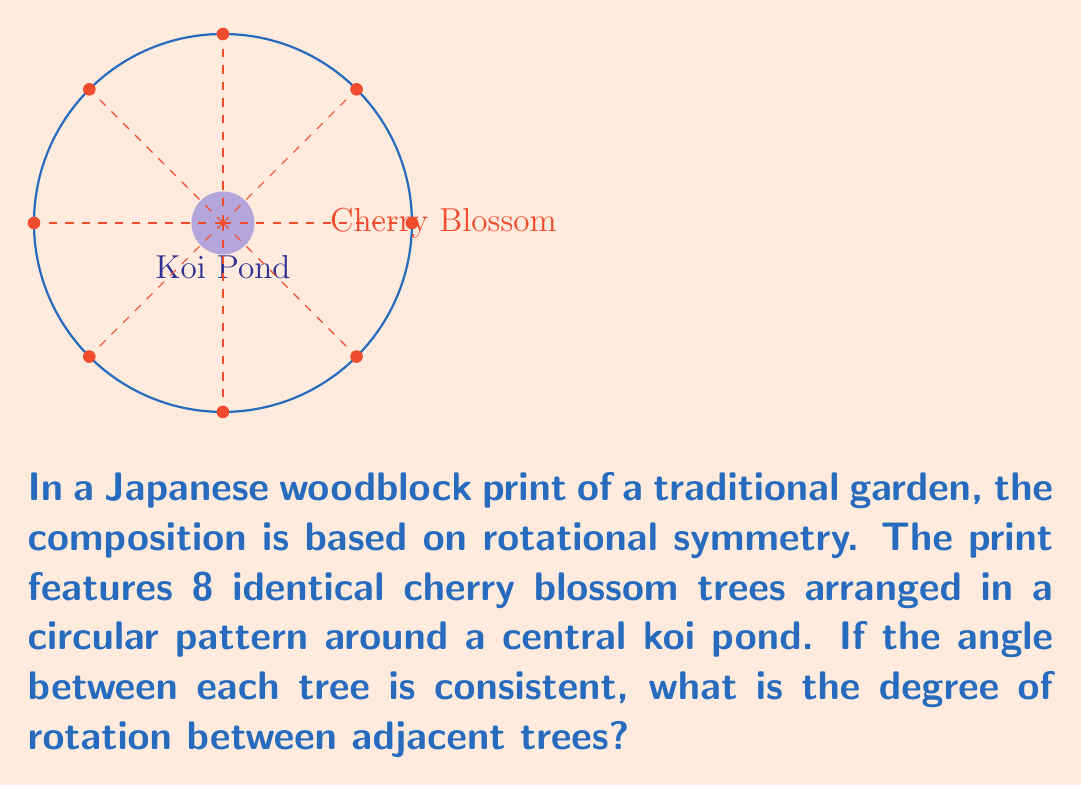Help me with this question. To solve this problem, we need to understand the concept of rotational symmetry in a circular arrangement:

1. In a complete circle, there are 360°.

2. The trees are evenly spaced around the circle, forming 8 equal segments.

3. To find the angle between adjacent trees, we need to divide the total degrees in a circle by the number of segments:

   $$\text{Angle} = \frac{\text{Total degrees}}{\text{Number of segments}}$$

4. Substituting the values:

   $$\text{Angle} = \frac{360°}{8} = 45°$$

This result aligns with the artistic principle of balance in Japanese woodblock prints, where symmetry often plays a crucial role in composition. The 45° rotation creates a harmonious and visually pleasing arrangement that would be typical in ukiyo-e landscapes, which greatly influenced Van Gogh's later works.
Answer: 45° 